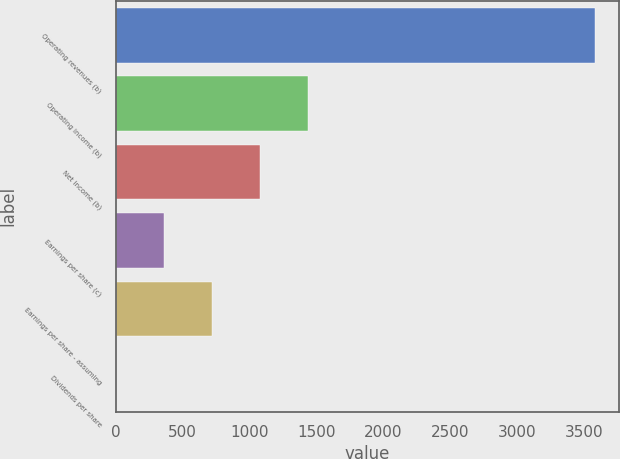<chart> <loc_0><loc_0><loc_500><loc_500><bar_chart><fcel>Operating revenues (b)<fcel>Operating income (b)<fcel>Net income (b)<fcel>Earnings per share (c)<fcel>Earnings per share - assuming<fcel>Dividends per share<nl><fcel>3585<fcel>1434.28<fcel>1075.83<fcel>358.91<fcel>717.37<fcel>0.45<nl></chart> 